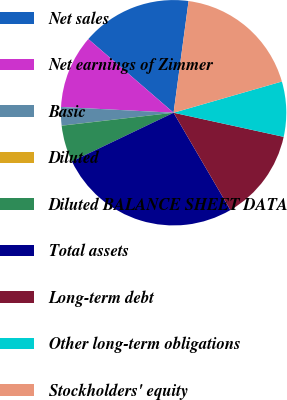Convert chart to OTSL. <chart><loc_0><loc_0><loc_500><loc_500><pie_chart><fcel>Net sales<fcel>Net earnings of Zimmer<fcel>Basic<fcel>Diluted<fcel>Diluted BALANCE SHEET DATA<fcel>Total assets<fcel>Long-term debt<fcel>Other long-term obligations<fcel>Stockholders' equity<nl><fcel>15.78%<fcel>10.53%<fcel>2.64%<fcel>0.01%<fcel>5.27%<fcel>26.3%<fcel>13.16%<fcel>7.9%<fcel>18.41%<nl></chart> 